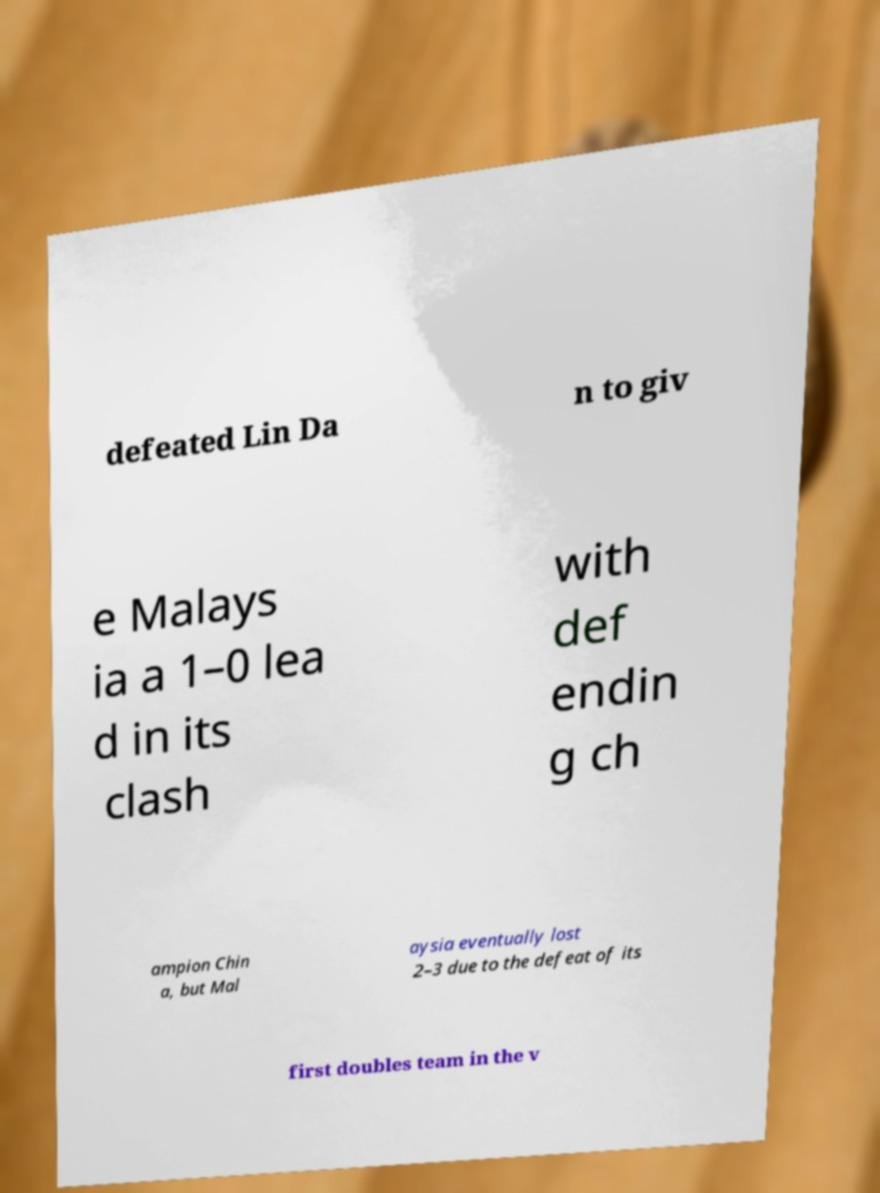Could you extract and type out the text from this image? defeated Lin Da n to giv e Malays ia a 1–0 lea d in its clash with def endin g ch ampion Chin a, but Mal aysia eventually lost 2–3 due to the defeat of its first doubles team in the v 